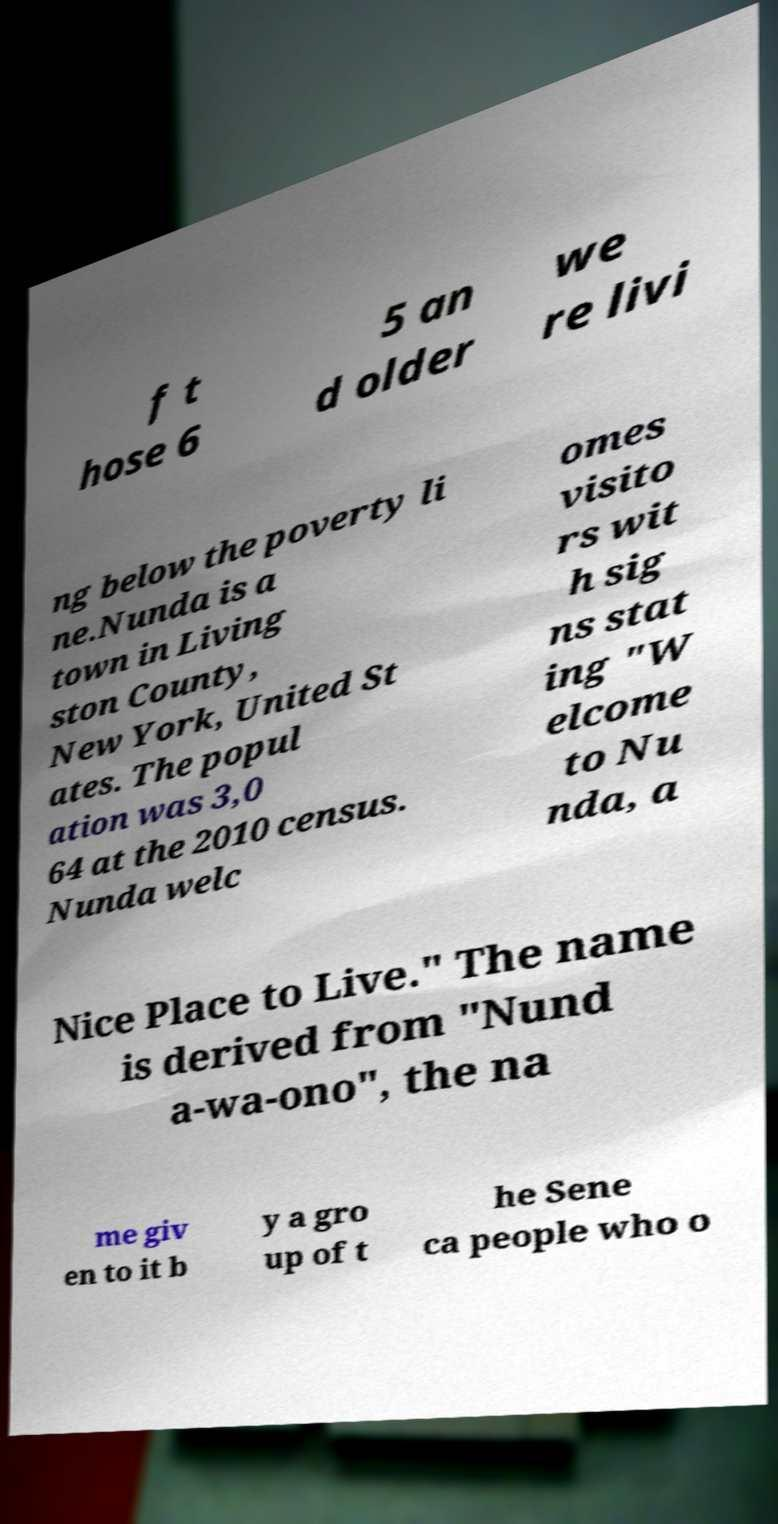There's text embedded in this image that I need extracted. Can you transcribe it verbatim? f t hose 6 5 an d older we re livi ng below the poverty li ne.Nunda is a town in Living ston County, New York, United St ates. The popul ation was 3,0 64 at the 2010 census. Nunda welc omes visito rs wit h sig ns stat ing "W elcome to Nu nda, a Nice Place to Live." The name is derived from "Nund a-wa-ono", the na me giv en to it b y a gro up of t he Sene ca people who o 